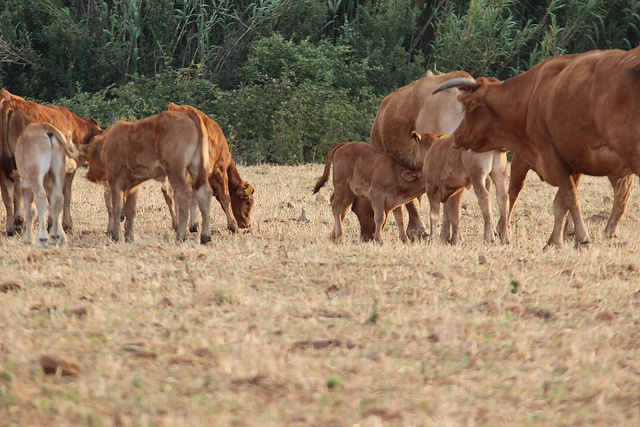Describe the objects in this image and their specific colors. I can see cow in black, maroon, and brown tones, cow in black, brown, gray, and maroon tones, cow in black, gray, brown, and maroon tones, cow in black, brown, and maroon tones, and cow in black, darkgray, and gray tones in this image. 